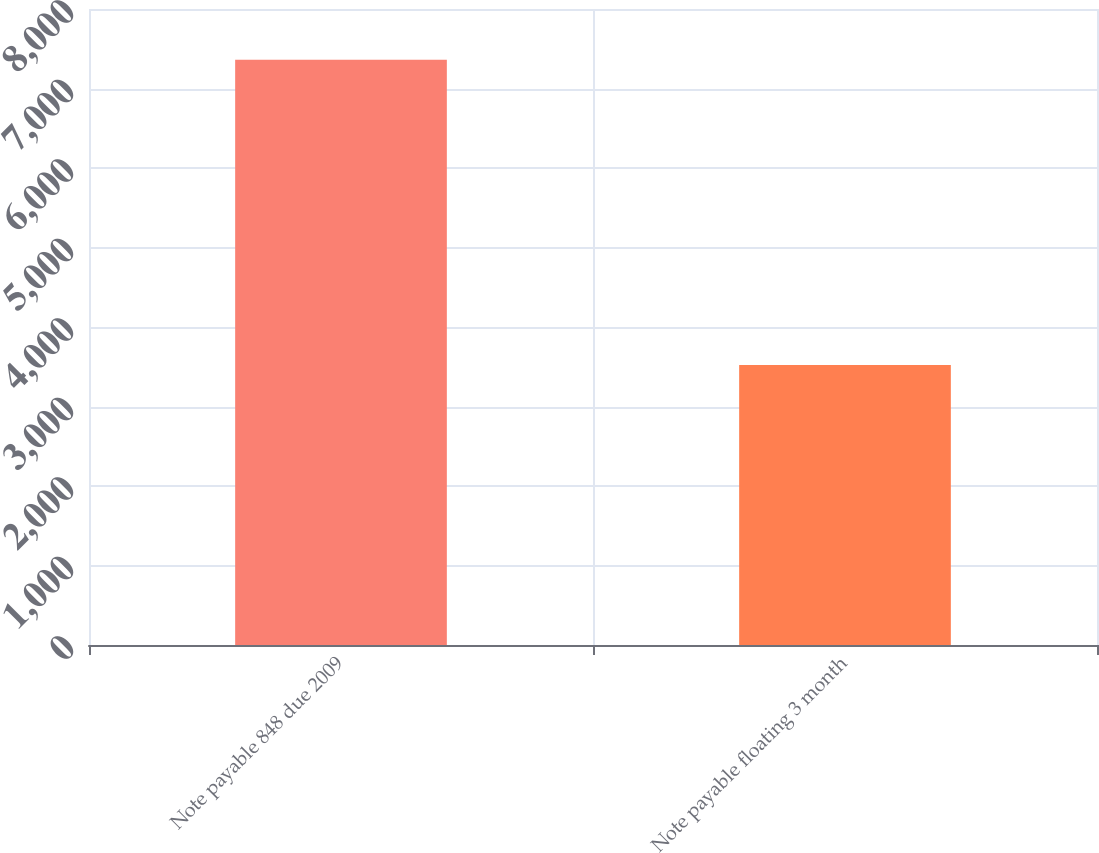Convert chart to OTSL. <chart><loc_0><loc_0><loc_500><loc_500><bar_chart><fcel>Note payable 848 due 2009<fcel>Note payable floating 3 month<nl><fcel>7363<fcel>3523<nl></chart> 